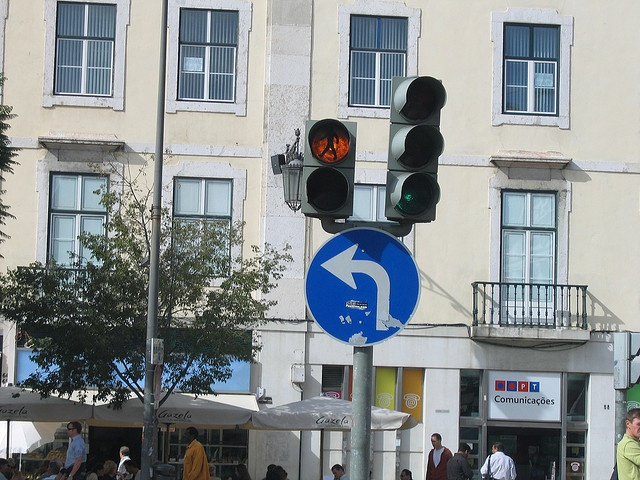Describe the objects in this image and their specific colors. I can see traffic light in lightgray, black, gray, and darkgray tones, traffic light in lightgray, black, gray, maroon, and darkgray tones, umbrella in lightgray, darkgray, and gray tones, umbrella in lightgray, gray, black, and darkgray tones, and umbrella in lightgray, gray, and black tones in this image. 